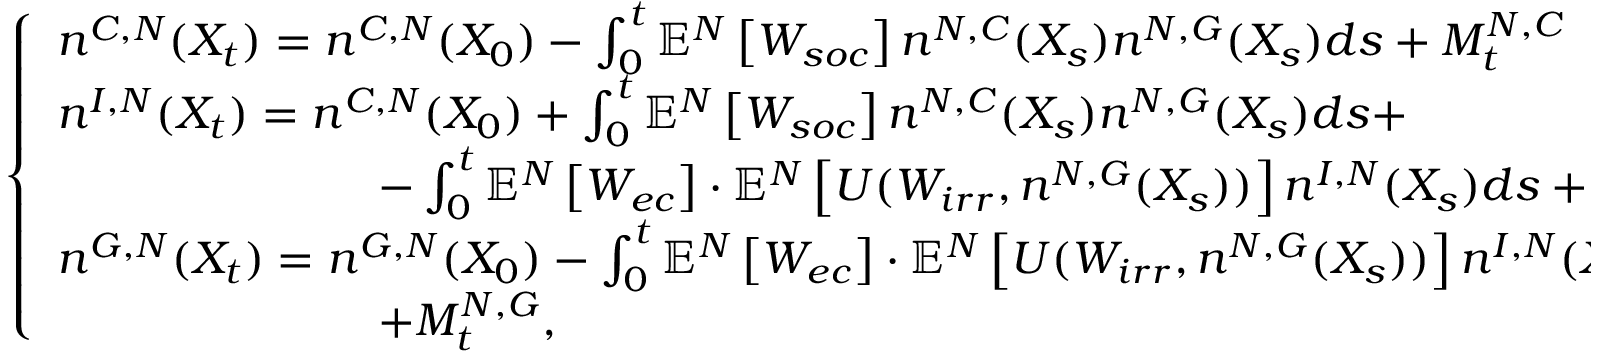<formula> <loc_0><loc_0><loc_500><loc_500>\left \{ \begin{array} { l l } { n ^ { C , N } ( X _ { t } ) = n ^ { C , N } ( X _ { 0 } ) - \int _ { 0 } ^ { t } \mathbb { E } ^ { N } \left [ W _ { s o c } \right ] n ^ { N , C } ( X _ { s } ) n ^ { N , G } ( X _ { s } ) d s + M _ { t } ^ { N , C } } \\ { n ^ { I , N } ( X _ { t } ) = n ^ { C , N } ( X _ { 0 } ) + \int _ { 0 } ^ { t } \mathbb { E } ^ { N } \left [ W _ { s o c } \right ] n ^ { N , C } ( X _ { s } ) n ^ { N , G } ( X _ { s } ) d s + } \\ { \quad - \int _ { 0 } ^ { t } \mathbb { E } ^ { N } \left [ W _ { e c } \right ] \cdot \mathbb { E } ^ { N } \left [ U ( W _ { i r r } , n ^ { N , G } ( X _ { s } ) ) \right ] n ^ { I , N } ( X _ { s } ) d s + M _ { t } ^ { N , I } } \\ { n ^ { G , N } ( X _ { t } ) = n ^ { G , N } ( X _ { 0 } ) - \int _ { 0 } ^ { t } \mathbb { E } ^ { N } \left [ W _ { e c } \right ] \cdot \mathbb { E } ^ { N } \left [ U ( W _ { i r r } , n ^ { N , G } ( X _ { s } ) ) \right ] n ^ { I , N } ( X _ { s } ) d s } \\ { \quad + M _ { t } ^ { N , G } , } \end{array}</formula> 